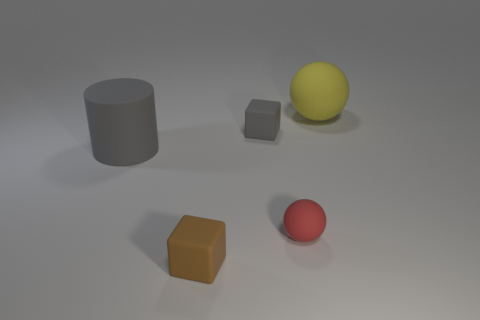Is there a gray rubber cube that is in front of the large object in front of the gray object that is to the right of the large gray matte object?
Your answer should be compact. No. The other big thing that is made of the same material as the large gray thing is what color?
Make the answer very short. Yellow. How big is the matte object that is on the right side of the small gray cube and behind the gray cylinder?
Provide a succinct answer. Large. Is the number of objects in front of the tiny brown block less than the number of gray things right of the large gray matte cylinder?
Offer a terse response. Yes. Are the sphere behind the red sphere and the block in front of the small ball made of the same material?
Your answer should be very brief. Yes. There is a tiny object that is the same color as the cylinder; what material is it?
Offer a terse response. Rubber. What shape is the tiny rubber thing that is to the right of the tiny brown rubber object and in front of the tiny gray cube?
Your answer should be compact. Sphere. What material is the gray thing left of the tiny rubber cube in front of the gray cylinder?
Provide a succinct answer. Rubber. Are there more large spheres than gray things?
Your answer should be compact. No. Is the big ball the same color as the tiny rubber ball?
Provide a succinct answer. No. 